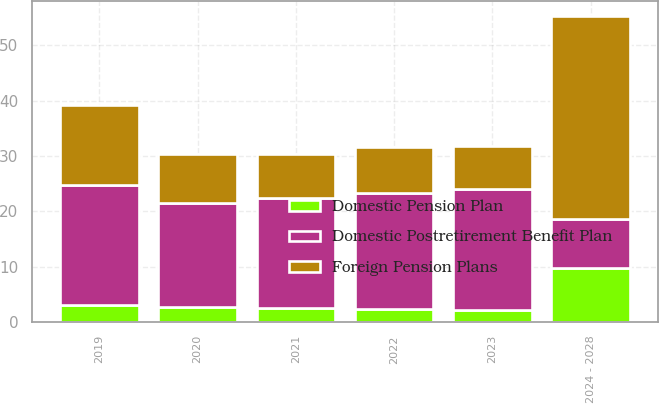Convert chart to OTSL. <chart><loc_0><loc_0><loc_500><loc_500><stacked_bar_chart><ecel><fcel>2019<fcel>2020<fcel>2021<fcel>2022<fcel>2023<fcel>2024 - 2028<nl><fcel>Foreign Pension Plans<fcel>14.5<fcel>8.8<fcel>8<fcel>8.3<fcel>7.8<fcel>36.7<nl><fcel>Domestic Postretirement Benefit Plan<fcel>21.7<fcel>18.7<fcel>19.8<fcel>20.9<fcel>21.8<fcel>8.8<nl><fcel>Domestic Pension Plan<fcel>3<fcel>2.8<fcel>2.6<fcel>2.4<fcel>2.2<fcel>9.8<nl></chart> 